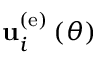Convert formula to latex. <formula><loc_0><loc_0><loc_500><loc_500>{ u } _ { i } ^ { \left ( e \right ) } \left ( \theta \right )</formula> 